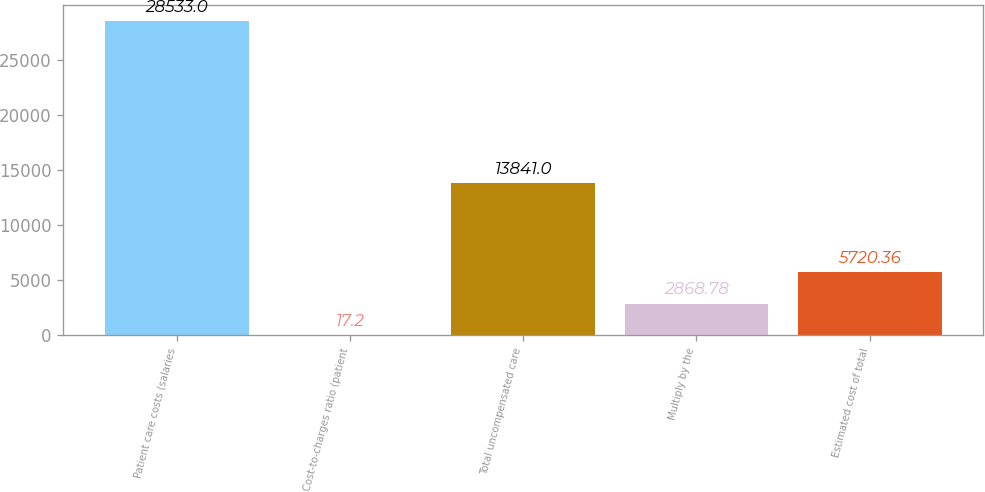Convert chart to OTSL. <chart><loc_0><loc_0><loc_500><loc_500><bar_chart><fcel>Patient care costs (salaries<fcel>Cost-to-charges ratio (patient<fcel>Total uncompensated care<fcel>Multiply by the<fcel>Estimated cost of total<nl><fcel>28533<fcel>17.2<fcel>13841<fcel>2868.78<fcel>5720.36<nl></chart> 